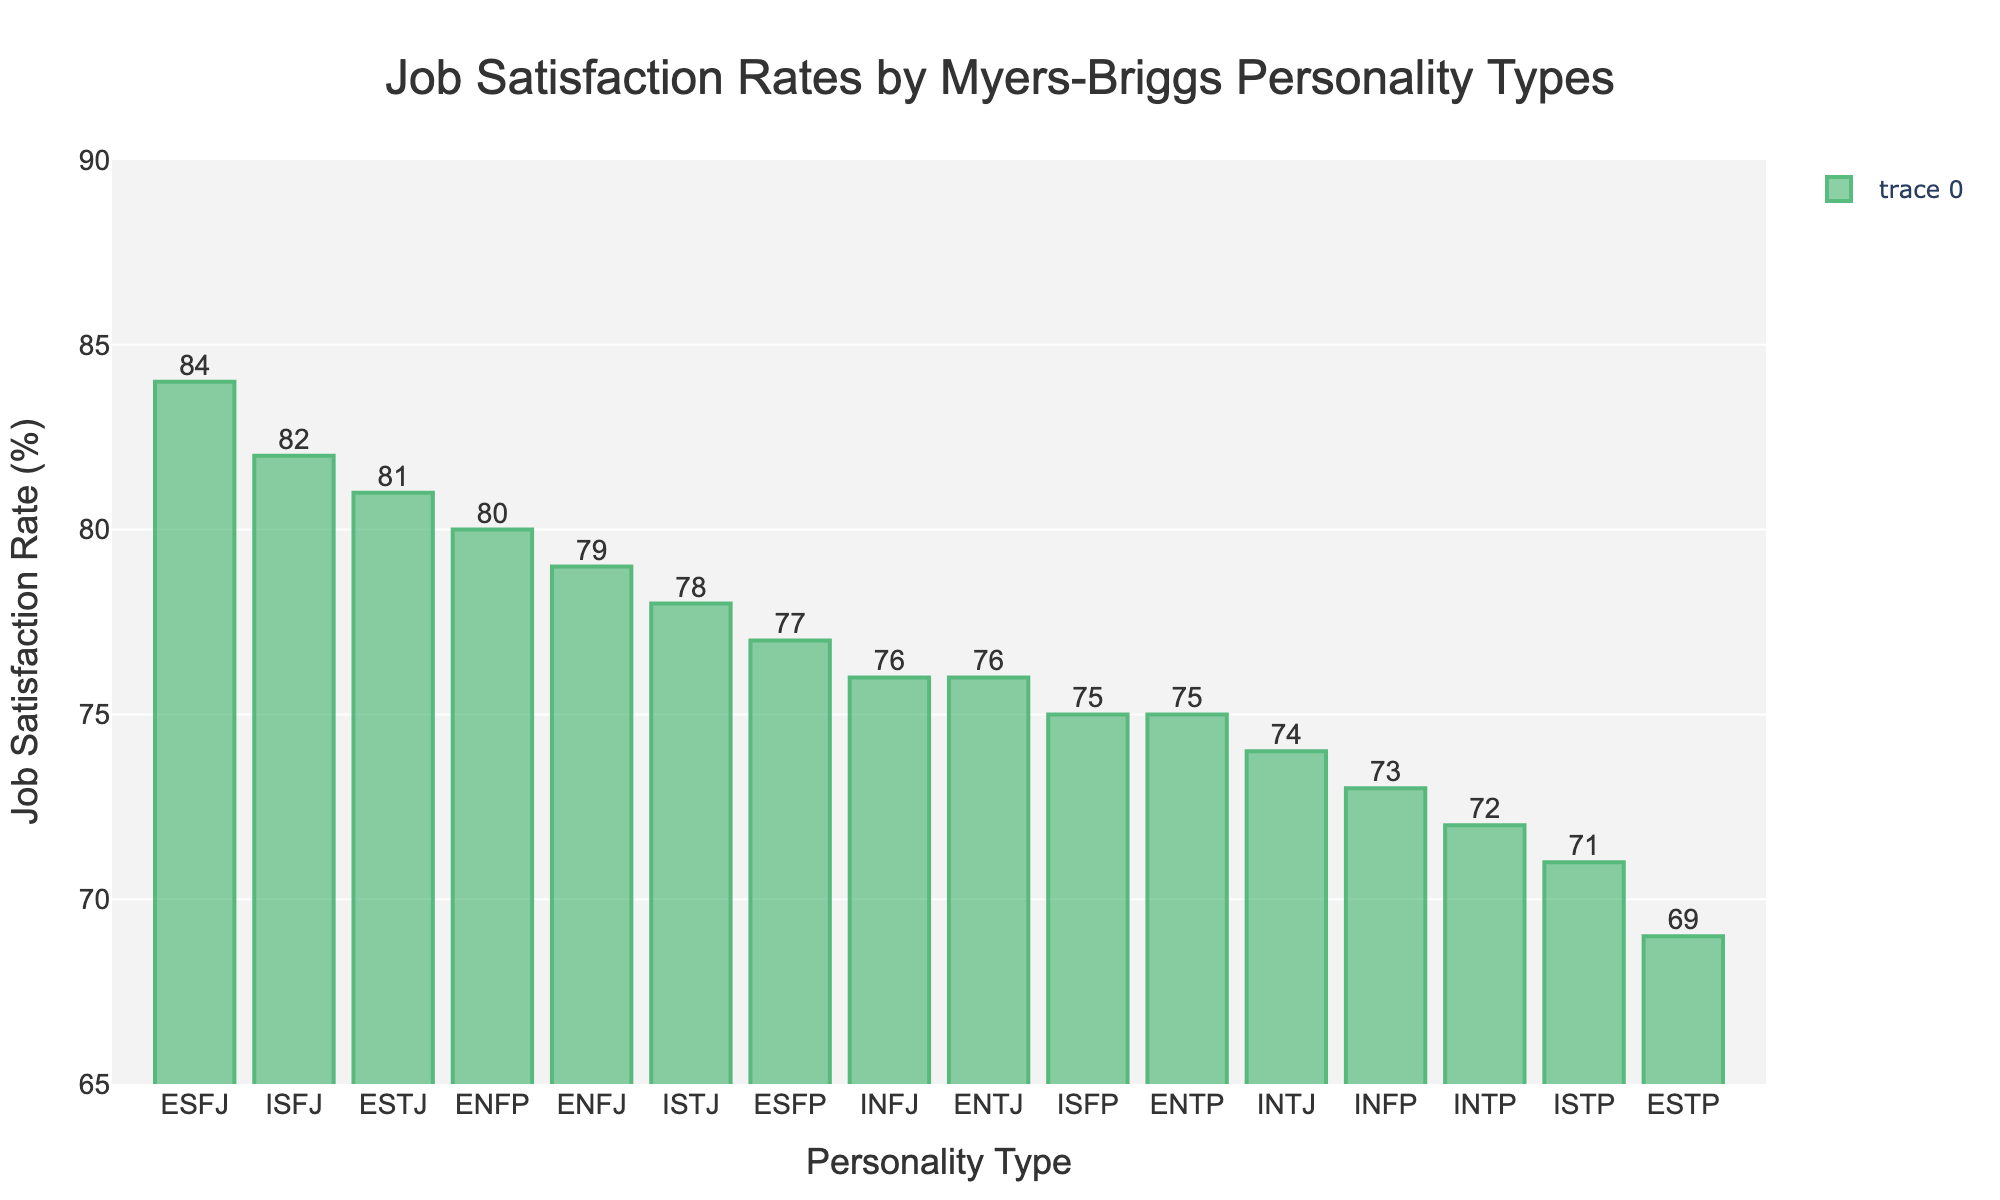Which personality type has the highest job satisfaction rate? Scan the bar heights or labels to identify the tallest bar or the highest numerical value. ESFJ has the highest satisfaction rate at 84%.
Answer: ESFJ Which personality type has the lowest job satisfaction rate? Identify the shortest bar or the smallest numerical value among the rates. ESTP has the lowest satisfaction rate at 69%.
Answer: ESTP What is the difference in job satisfaction rates between ESFJ and ESTP? Find and subtract the satisfaction rate of ESTP from that of ESFJ: 84 - 69 = 15.
Answer: 15% Which types have job satisfaction rates above 80%? Identify bars with values exceeding 80%: ISFJ, ENFP, ESFJ, ESTJ.
Answer: ISFJ, ENFP, ESFJ, ESTJ How many personality types have a job satisfaction rate of 76%? Count all bars or data points with the value 76. INFJ and ENTJ both show 76%.
Answer: 2 Calculate the average job satisfaction rate for EST types (ESTJ & ESTP). Find and average the rates: (81 + 69) / 2 = 75.
Answer: 75% Compare job satisfaction rates for introverted types: ISTJ, ISFJ, INFJ, INTJ. Which has the highest and lowest rates? Identify introverts among the listed types and find their satisfaction. ISFJ leads at 82% and ISTP is lowest at 71%.
Answer: ISFJ 82%, ISTP 71% How many personality types have job satisfaction rates between 70% and 75% inclusive? Count the bars with rates in the given range: ISTP, ISFP, INFP, INTP, ENTP, ENFP.
Answer: 6 Which is greater: the average job satisfaction rate for extroverted types or introverted types? Calculate average rates for extroverted (ESTP, ESFP, ENFP, ENTP, ESTJ, ESFJ, ENFJ, ENTJ) and introverted types (ISTJ, ISFJ, INFJ, INTJ, ISTP, ISFP, INFP, INTP). Compare averages.
Answer: Introverted What is the median job satisfaction rate of the given data set? Sort the rates: 69, 71, 72, 73, 74, 75, 75, 76, 76, 77, 78, 79, 80, 81, 82, 84. Find the middle value(s), which is 75.5% (average of 75 and 76).
Answer: 75.5% 